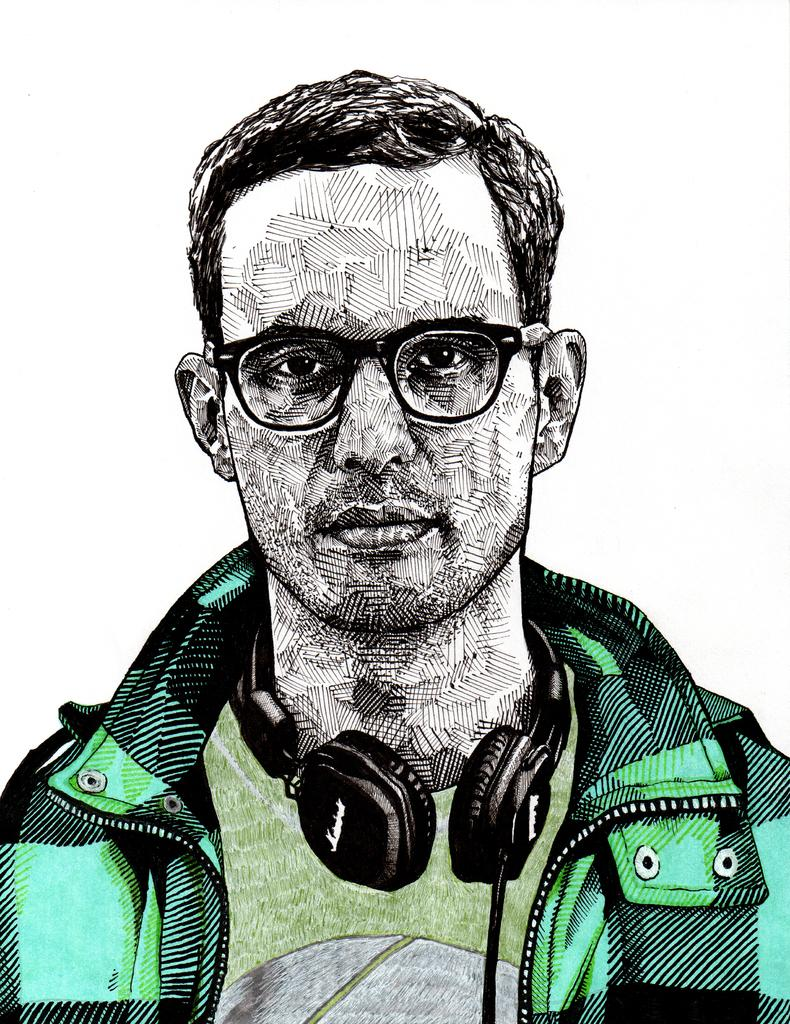What is: What is depicted in the image? There is a sketch of a man in the image. What is the man wearing on his upper body? The man is wearing a green jacket. What is the man wearing on his head? The man is wearing black headphones. What type of eyewear is the man wearing? The man is wearing specs. What color is the background of the image? The background of the image is white. How many apples are on the man's head in the image? There are no apples present in the image; the man is wearing black headphones. What type of lipstick is the man wearing in the image? The man is not wearing any lipstick in the image, as he is a sketch and not a real person. 